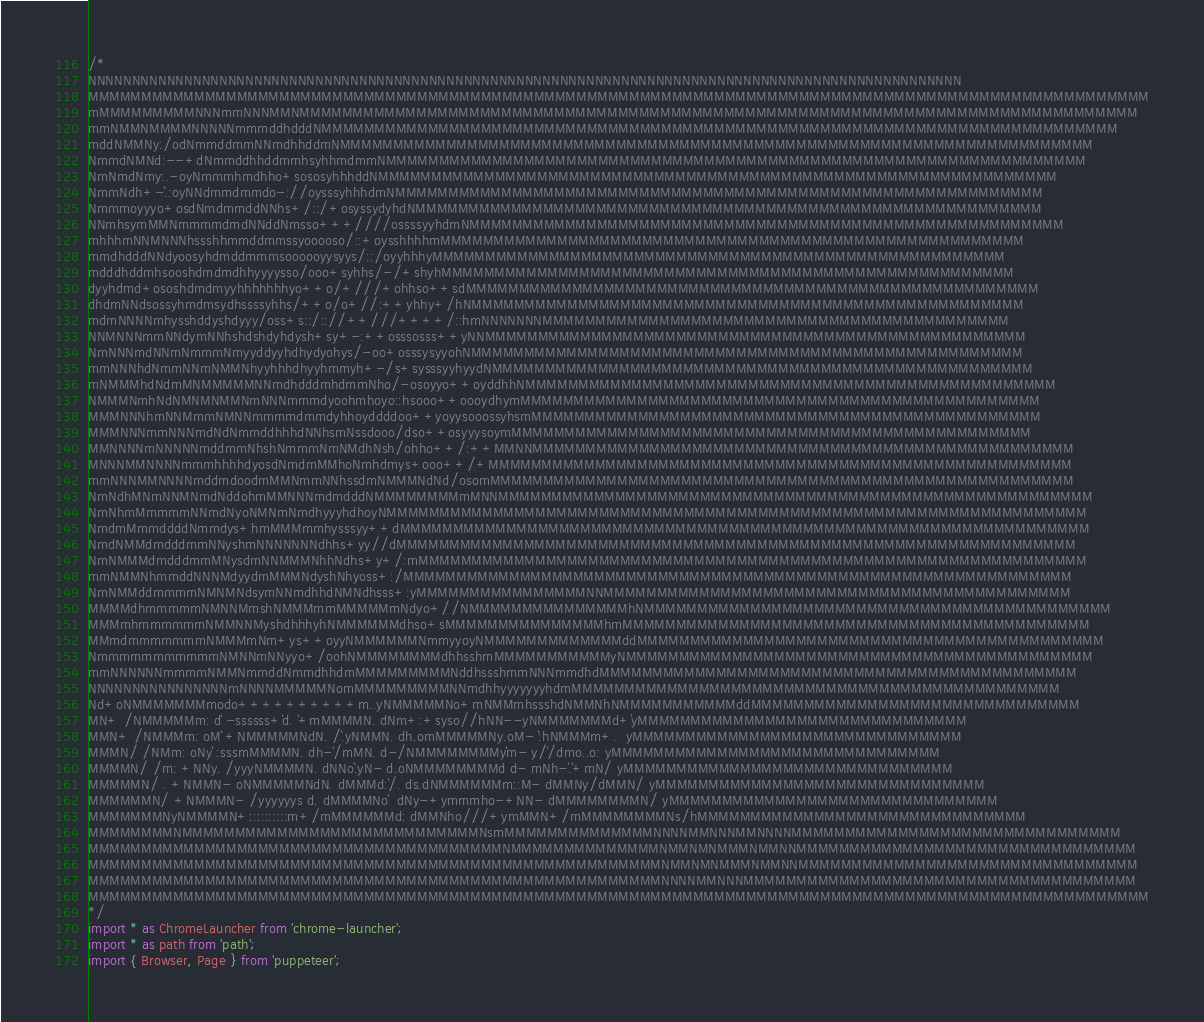<code> <loc_0><loc_0><loc_500><loc_500><_TypeScript_>/*
NNNNNNNNNNNNNNNNNNNNNNNNNNNNNNNNNNNNNNNNNNNNNNNNNNNNNNNNNNNNNNNNNNNNNNNNNNNNNNNNNNNNNNNNNNNNNNNNNNNN
MMMMMMMMMMMMMMMMMMMMMMMMMMMMMMMMMMMMMMMMMMMMMMMMMMMMMMMMMMMMMMMMMMMMMMMMMMMMMMMMMMMMMMMMMMMMMMMMMMMM
mMMMMMMMMMNNNmmNNNMMNMMMMMMMMMMMMMMMMMMMMMMMMMMMMMMMMMMMMMMMMMMMMMMMMMMMMMMMMMMMMMMMMMMMMMMMMMMMMMMM
mmNMMNMMMMNNNNNmmmddhdddNMMMMMMMMMMMMMMMMMMMMMMMMMMMMMMMMMMMMMMMMMMMMMMMMMMMMMMMMMMMMMMMMMMMMMMMMMMM
mddNMMNy:/odNmmddmmNNmdhhddmNMMMMMMMMMMMMMMMMMMMMMMMMMMMMMMMMMMMMMMMMMMMMMMMMMMMMMMMMMMMMMMMMMMMMMMM
NmmdNMNd:--+dNmmddhhddmmhsyhhmdmmNMMMMMMMMMMMMMMMMMMMMMMMMMMMMMMMMMMMMMMMMMMMMMMMMMMMMMMMMMMMMMMMMMM
NmNmdNmy:.-oyNmmmhmdhho+sososyhhhddNMMMMMMMMMMMMMMMMMMMMMMMMMMMMMMMMMMMMMMMMMMMMMMMMMMMMMMMMMMMMMMMM
NmmNdh+-`.:oyNNdmmdmmdo-://oysssyhhhdmNMMMMMMMMMMMMMMMMMMMMMMMMMMMMMMMMMMMMMMMMMMMMMMMMMMMMMMMMMMMMM
Nmmmoyyyo+osdNmdmmddNNhs+/::/+osyssydyhdNMMMMMMMMMMMMMMMMMMMMMMMMMMMMMMMMMMMMMMMMMMMMMMMMMMMMMMMMMMM
NNmhsymMMNmmmmdmdNNddNmsso+++////ossssyyhdmNMMMMMMMMMMMMMMMMMMMMMMMMMMMMMMMMMMMMMMMMMMMMMMMMMMMMMMMM
mhhhmNNMNNNhssshhmmddmmssyooooso/::+oysshhhhmMMMMMMMMMMMMMMMMMMMMMMMMMMMMMMMMMMMMMMMMMMMMMMMMMMMMMMM
mmdhdddNNdyoosyhdmddmmmsoooooyysyys/::/oyyhhhyMMMMMMMMMMMMMMMMMMMMMMMMMMMMMMMMMMMMMMMMMMMMMMMMMMMMMM
mdddhddmhsooshdmdmdhhyyyysso/ooo+syhhs/-/+shyhMMMMMMMMMMMMMMMMMMMMMMMMMMMMMMMMMMMMMMMMMMMMMMMMMMMMMM
dyyhdmd+ososhdmdmyyhhhhhhhyo++o/+///+ohhso++sdMMMMMMMMMMMMMMMMMMMMMMMMMMMMMMMMMMMMMMMMMMMMMMMMMMMMMM
dhdmNNdsossyhmdmsydhssssyhhs/++o/o+//:++yhhy+/hNMMMMMMMMMMMMMMMMMMMMMMMMMMMMMMMMMMMMMMMMMMMMMMMMMMMM
mdmNNNNmhysshddyshdyyy/oss+s::/:://++///++++/::hmNNNNNNNMMMMMMMMMMMMMMMMMMMMMMMMMMMMMMMMMMMMMMMMMMMM
NNMNNNmmNNdymNNhshdshdyhdysh+sy+-:++osssosss++yNNMMMMMMMMMMMMMMMMMMMMMMMMMMMMMMMMMMMMMMMMMMMMMMMMMMM
NmNNNmdNNmNmmmNmyyddyyhdhydyohys/-oo+osssysyyohNMMMMMMMMMMMMMMMMMMMMMMMMMMMMMMMMMMMMMMMMMMMMMMMMMMMM
mmNNNhdNmmNNmNMMNhyyhhhdhyyhmmyh+-/s+sysssyyhyydNMMMMMMMMMMMMMMMMMMMMMMMMMMMMMMMMMMMMMMMMMMMMMMMMMMM
mNMMMhdNdmMNMMMMMNNmdhdddmhdmmNho/-osoyyo++oyddhhNMMMMMMMMMMMMMMMMMMMMMMMMMMMMMMMMMMMMMMMMMMMMMMMMMM
NMMMNmhNdNMNMNMMNmNNNmmmdyoohmhoyo::hsooo++oooydhymMMMMMMMMMMMMMMMMMMMMMMMMMMMMMMMMMMMMMMMMMMMMMMMMM
MMMNNNhmNNMmmNMNNmmmmdmmdyhhoyddddoo++yoyysooossyhsmMMMMMMMMMMMMMMMMMMMMMMMMMMMMMMMMMMMMMMMMMMMMMMMM
MMMNNNmmNNNmdNdNmmddhhhdNNhsmNssdooo/dso++osyyysoymMMMMMMMMMMMMMMMMMMMMMMMMMMMMMMMMMMMMMMMMMMMMMMMMM
MMNNNNmNNNNNmddmmNhshNmmmNmNMdhNsh/ohho++/:++MMNNMMMMMMMMMMMMMMMMMMMMMMMMMMMMMMMMMMMMMMMMMMMMMMMMMMM
MNNNMMNNNNmmmhhhhdyosdNmdmMMhoNmhdmys+ooo++/+MMMMMMMMMMMMMMMMMMMMMMMMMMMMMMMMMMMMMMMMMMMMMMMMMMMMMMM
mmNNNMMNNNNmddmdoodmMMNmmNNhssdmNMMMNdNd/osomMMMMMMMMMMMMMMMMMMMMMMMMMMMMMMMMMMMMMMMMMMMMMMMMMMMMMMM
NmNdhMNmNNMNmdNddohmMMNNNmdmdddNMMMMMMMMmMNNMMMMMMMMMMMMMMMMMMMMMMMMMMMMMMMMMMMMMMMMMMMMMMMMMMMMMMMM
NmNhmMmmmmNNmdNyoNMNmNmdhyyyhdhoyNMMMMMMMMMMMMMMMMMMMMMMMMMMMMMMMMMMMMMMMMMMMMMMMMMMMMMMMMMMMMMMMMMM
NmdmMmmddddNmmdys+hmMMMmmhysssyy++dMMMMMMMMMMMMMMMMMMMMMMMMMMMMMMMMMMMMMMMMMMMMMMMMMMMMMMMMMMMMMMMMM
NmdNMMdmdddmmNNyshmNNNNNNNdhhs+yy//dMMMMMMMMMMMMMMMMMMMMMMMMMMMMMMMMMMMMMMMMMMMMMMMMMMMMMMMMMMMMMMMM
NmNMMMdmdddmmMNysdmNNMMMNhhNdhs+y+/:mMMMMMMMMMMMMMMMMMMMMMMMMMMMMMMMMMMMMMMMMMMMMMMMMMMMMMMMMMMMMMMM
mmNMMNhmmddNNNMdyydmMMMNdyshNhyoss+:/MMMMMMMMMMMMMMMMMMMMMMMMMMMMMMMMMMMMMMMMMMMMMMMMMMMMMMMMMMMMMMM
NmNMMddmmmmNMNMNdsymNNmdhhdNMNdhsss+:yMMMMMMMMMMMMMMMMNNMMMMMMMMMMMMMMMMMMMMMMMMMMMMMMMMMMMMMMMMMMMM
MMMMdhmmmmmNMNNMmshNMMMmmMMMMMmNdyo+//NMMMMMMMMMMMMMMMhNMMMMMMMMMMMMMMMMMMMMMMMMMMMMMMMMMMMMMMMMMMMM
MMMmhmmmmmmNMMNNMyshdhhhyhNMMMMMMdhso+sMMMMMMMMMMMMMMMhmMMMMMMMMMMMMMMMMMMMMMMMMMMMMMMMMMMMMMMMMMMMM
MMmdmmmmmmmNMMMmNm+ys++oyyNMMMMMMNmmyyoyNMMMMMMMMMMMMMddMMMMMMMMMMMMMMMMMMMMMMMMMMMMMMMMMMMMMMMMMMMM
NmmmmmmmmmmmNMNNmNNyyo+/oohNMMMMMMMMdhhsshmMMMMMMMMMMMyNMMMMMMMMMMMMMMMMMMMMMMMMMMMMMMMMMMMMMMMMMMMM
mmNNNNNNmmmmNMMNmmddNmmdhhdmMMMMMMMMMNddhssshmmNNNmmdhdMMMMMMMMMMMMMMMMMMMMMMMMMMMMMMMMMMMMMMMMMMMMM
NNNNNNNNNNNNNNNNmNNNNMMMMMNomMMMMMMMMMNNmdhhyyyyyyyhdmMMMMMMMMMMMMMMMMMMMMMMMMMMMMMMMMMMMMMMMMMMMMMM
Nd+oNMMMMMMMmodo++++++++++m..yNMMMMMNo+mNMMmhssshdNMMNhNMMMMMMMMMMMddMMMMMMMMMMMMMMMMMMMMMMMMMMMMMMM
MN+ /NMMMMMm: d` -ssssss+`d. `+mMMMMN. dNm+:+syso//hNN--yNMMMMMMMd+`yMMMMMMMMMMMMMMMMMMMMMMMMMMMMMMM
MMN+ /NMMMm: oM` +NMMMMMNdN. /`.yNMMN. dh.omMMMMMNy.oM- `:hNMMMm+.  yMMMMMMMMMMMMMMMMMMMMMMMMMMMMMMM
MMMN/ /NMm: oNy` :sssmMMMMN. dh-`/mMN. d-/NMMMMMMMMy`m- y/`/dmo..o: yMMMMMMMMMMMMMMMMMMMMMMMMMMMMMMM
MMMMN/ /m: +NNy. /yyyNMMMMN. dNNo`.yN- d.oNMMMMMMMMd d- mNh-`.`+mN/ yMMMMMMMMMMMMMMMMMMMMMMMMMMMMMMM
MMMMMN/ . +NMMN- oNMMMMMNdN. dMMMd:`/. ds.dNMMMMMMm::M- dMMNy/dMMN/ yMMMMMMMMMMMMMMMMMMMMMMMMMMMMMMM
MMMMMMN/ +NMMMN- /yyyyyys d. dMMMMNo`  dNy-+ymmmho-+NN- dMMMMMMMMN/ yMMMMMMMMMMMMMMMMMMMMMMMMMMMMMMM
MMMMMMMNyNMMMMN+::::::::::m+/mMMMMMMd: dMMNho///+ymMMN+/mMMMMMMMMNs/hMMMMMMMMMMMMMMMMMMMMMMMMMMMMMMM
MMMMMMMMNMMMMMMMMMMMMMMMMMMMMMMMMMMMMNsmMMMMMMMMMMMMMMNNNNMMNNNMMNNNNMMMMMMMMMMMMMMMMMMMMMMMMMMMMMMM
MMMMMMMMMMMMMMMMMMMMMMMMMMMMMMMMMMMMMMMNMMMMMMMMMMMMMMNMMNMNMMMNMMNNMMMMMMMMMMMMMMMMMMMMMMMMMMMMMMMM
MMMMMMMMMMMMMMMMMMMMMMMMMMMMMMMMMMMMMMMMMMMMMMMMMMMMMMNMMNMNMMMNMMNNMMMMMMMMMMMMMMMMMMMMMMMMMMMMMMMM
MMMMMMMMMMMMMMMMMMMMMMMMMMMMMMMMMMMMMMMMMMMMMMMMMMMMMMNNNNMMNNNMMMMMMMMMMMMMMMMMMMMMMMMMMMMMMMMMMMMM
MMMMMMMMMMMMMMMMMMMMMMMMMMMMMMMMMMMMMMMMMMMMMMMMMMMMMMMMMMMMMMMMMMMMMMMMMMMMMMMMMMMMMMMMMMMMMMMMMMMM
*/
import * as ChromeLauncher from 'chrome-launcher';
import * as path from 'path';
import { Browser, Page } from 'puppeteer';</code> 